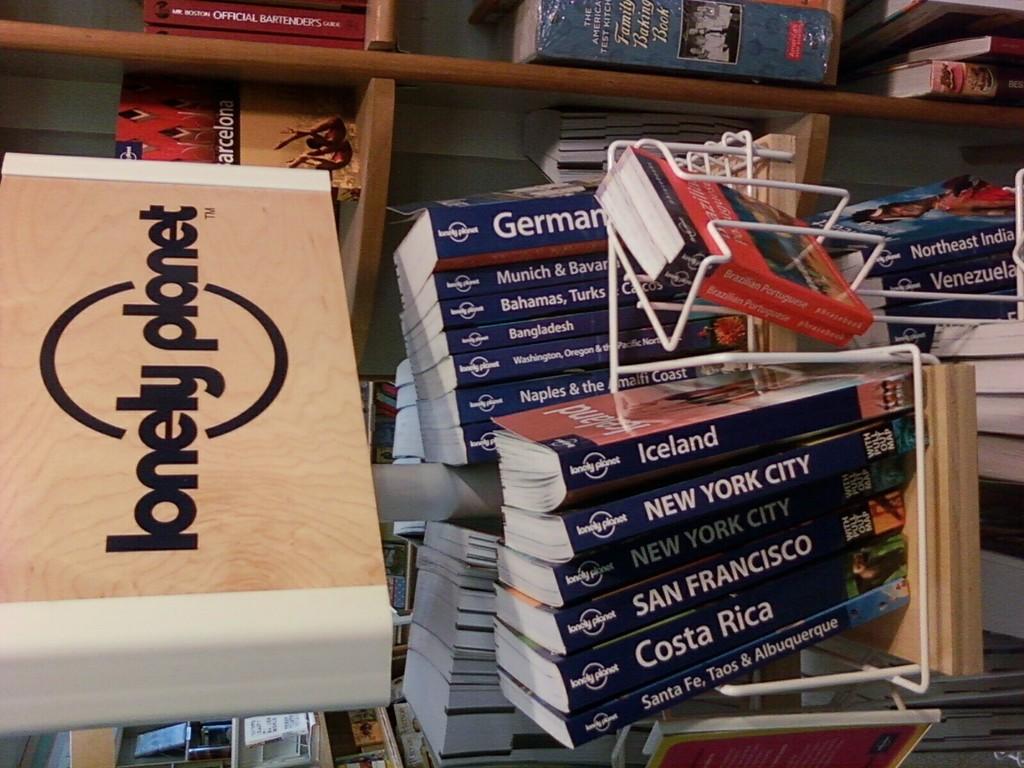What is the word in front of planet?
Offer a terse response. Lonely. What book is under iceland?
Give a very brief answer. New york city. 